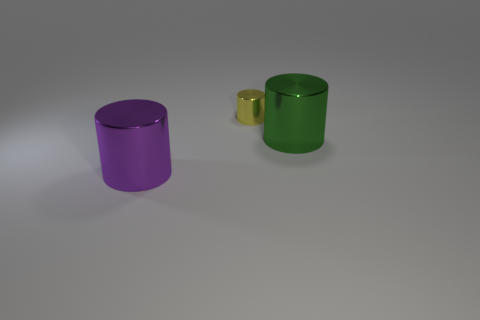Subtract all green metal cylinders. How many cylinders are left? 2 Subtract 1 cylinders. How many cylinders are left? 2 Add 2 large green shiny objects. How many objects exist? 5 Subtract all brown cylinders. Subtract all red cubes. How many cylinders are left? 3 Add 3 cylinders. How many cylinders are left? 6 Add 3 small shiny objects. How many small shiny objects exist? 4 Subtract 0 blue blocks. How many objects are left? 3 Subtract all cylinders. Subtract all green spheres. How many objects are left? 0 